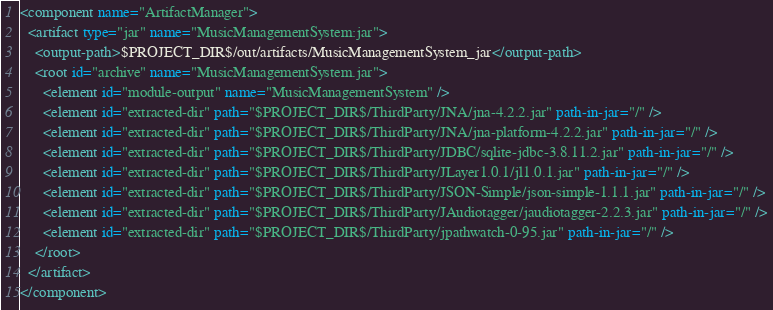<code> <loc_0><loc_0><loc_500><loc_500><_XML_><component name="ArtifactManager">
  <artifact type="jar" name="MusicManagementSystem:jar">
    <output-path>$PROJECT_DIR$/out/artifacts/MusicManagementSystem_jar</output-path>
    <root id="archive" name="MusicManagementSystem.jar">
      <element id="module-output" name="MusicManagementSystem" />
      <element id="extracted-dir" path="$PROJECT_DIR$/ThirdParty/JNA/jna-4.2.2.jar" path-in-jar="/" />
      <element id="extracted-dir" path="$PROJECT_DIR$/ThirdParty/JNA/jna-platform-4.2.2.jar" path-in-jar="/" />
      <element id="extracted-dir" path="$PROJECT_DIR$/ThirdParty/JDBC/sqlite-jdbc-3.8.11.2.jar" path-in-jar="/" />
      <element id="extracted-dir" path="$PROJECT_DIR$/ThirdParty/JLayer1.0.1/jl1.0.1.jar" path-in-jar="/" />
      <element id="extracted-dir" path="$PROJECT_DIR$/ThirdParty/JSON-Simple/json-simple-1.1.1.jar" path-in-jar="/" />
      <element id="extracted-dir" path="$PROJECT_DIR$/ThirdParty/JAudiotagger/jaudiotagger-2.2.3.jar" path-in-jar="/" />
      <element id="extracted-dir" path="$PROJECT_DIR$/ThirdParty/jpathwatch-0-95.jar" path-in-jar="/" />
    </root>
  </artifact>
</component></code> 